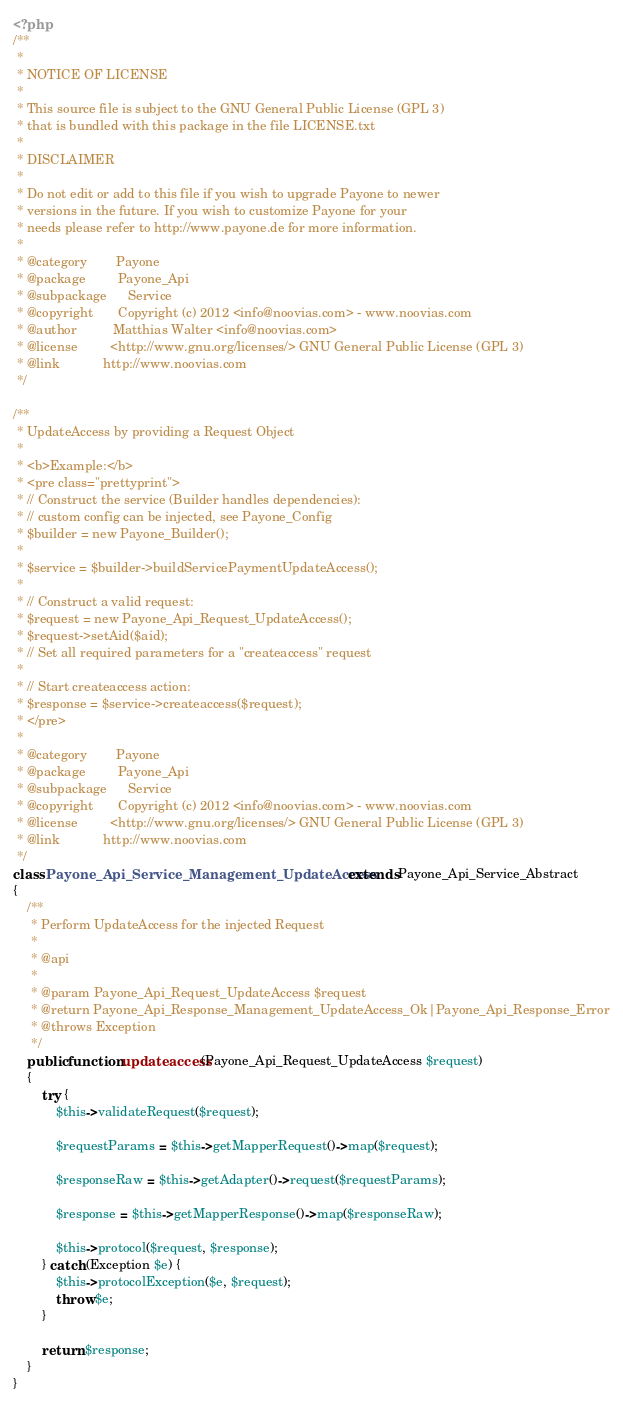Convert code to text. <code><loc_0><loc_0><loc_500><loc_500><_PHP_><?php
/**
 *
 * NOTICE OF LICENSE
 *
 * This source file is subject to the GNU General Public License (GPL 3)
 * that is bundled with this package in the file LICENSE.txt
 *
 * DISCLAIMER
 *
 * Do not edit or add to this file if you wish to upgrade Payone to newer
 * versions in the future. If you wish to customize Payone for your
 * needs please refer to http://www.payone.de for more information.
 *
 * @category        Payone
 * @package         Payone_Api
 * @subpackage      Service
 * @copyright       Copyright (c) 2012 <info@noovias.com> - www.noovias.com
 * @author          Matthias Walter <info@noovias.com>
 * @license         <http://www.gnu.org/licenses/> GNU General Public License (GPL 3)
 * @link            http://www.noovias.com
 */

/**
 * UpdateAccess by providing a Request Object
 *
 * <b>Example:</b>
 * <pre class="prettyprint">
 * // Construct the service (Builder handles dependencies):
 * // custom config can be injected, see Payone_Config
 * $builder = new Payone_Builder();
 *
 * $service = $builder->buildServicePaymentUpdateAccess();
 *
 * // Construct a valid request:
 * $request = new Payone_Api_Request_UpdateAccess();
 * $request->setAid($aid);
 * // Set all required parameters for a "createaccess" request
 *
 * // Start createaccess action:
 * $response = $service->createaccess($request);
 * </pre>
 *
 * @category        Payone
 * @package         Payone_Api
 * @subpackage      Service
 * @copyright       Copyright (c) 2012 <info@noovias.com> - www.noovias.com
 * @license         <http://www.gnu.org/licenses/> GNU General Public License (GPL 3)
 * @link            http://www.noovias.com
 */
class Payone_Api_Service_Management_UpdateAccess extends Payone_Api_Service_Abstract
{
    /**
     * Perform UpdateAccess for the injected Request
     *
     * @api
     *
     * @param Payone_Api_Request_UpdateAccess $request
     * @return Payone_Api_Response_Management_UpdateAccess_Ok|Payone_Api_Response_Error
     * @throws Exception
     */
    public function updateaccess(Payone_Api_Request_UpdateAccess $request)
    {
        try {
            $this->validateRequest($request);

            $requestParams = $this->getMapperRequest()->map($request);

            $responseRaw = $this->getAdapter()->request($requestParams);

            $response = $this->getMapperResponse()->map($responseRaw);

            $this->protocol($request, $response);
        } catch (Exception $e) {
            $this->protocolException($e, $request);
            throw $e;
        }

        return $response;
    }
}
</code> 